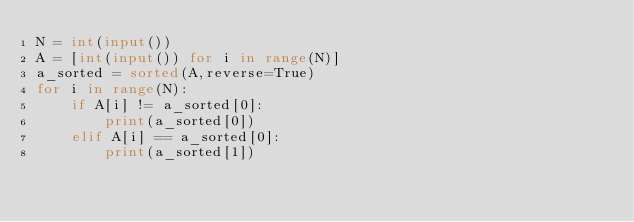<code> <loc_0><loc_0><loc_500><loc_500><_Python_>N = int(input())
A = [int(input()) for i in range(N)]
a_sorted = sorted(A,reverse=True)
for i in range(N):
    if A[i] != a_sorted[0]:
        print(a_sorted[0])
    elif A[i] == a_sorted[0]:
        print(a_sorted[1])</code> 